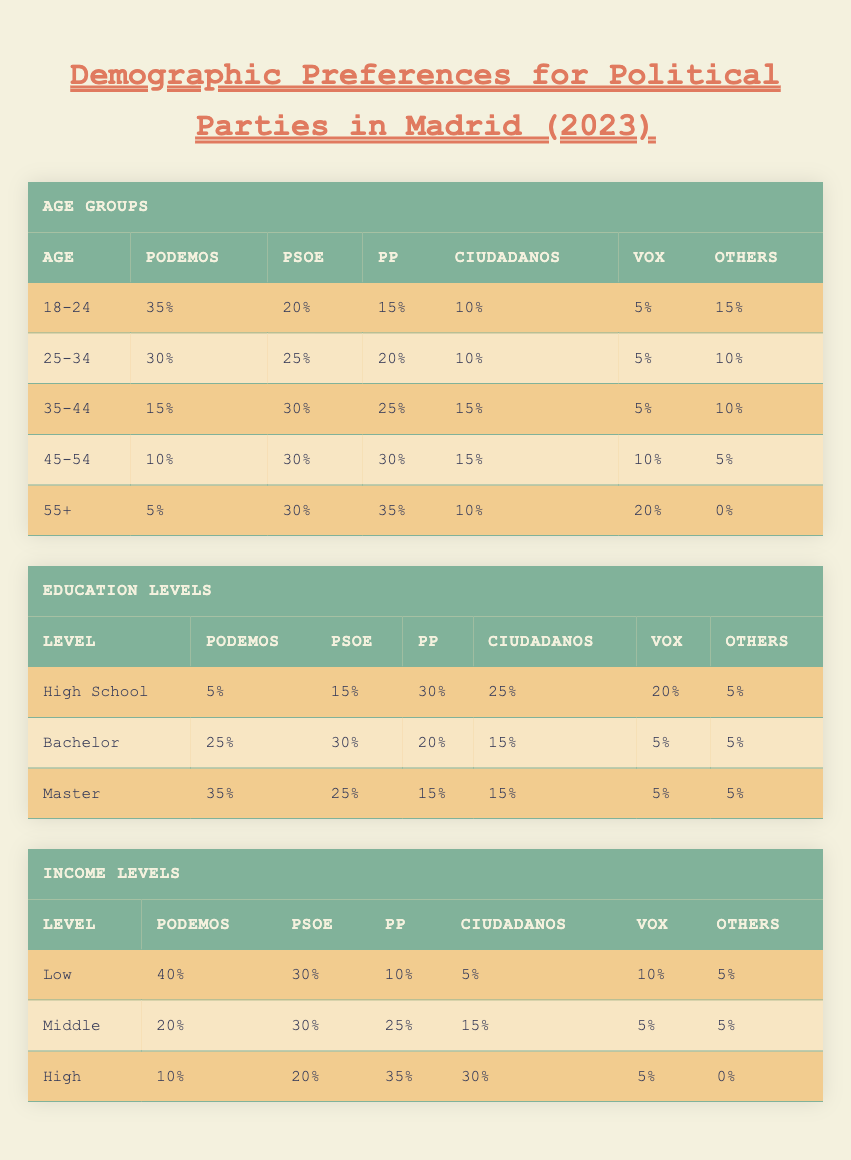What percentage of 18-24 year-olds support Podemos? Referring to the table, under the "Age Groups" section for the "18-24" category, Podemos has a support rate of 35%.
Answer: 35% Which party has the highest support among 45-54 year-olds? Looking at the "Age Groups" table for the "45-54" category, both PP and PSOE each have a support rate of 30%, which is the highest among this age group.
Answer: PP and PSOE What is the total support percentage for PSOE across all age groups? To find this, we sum the percentages of PSOE from each age group: 20 + 25 + 30 + 30 + 30 = 135.
Answer: 135% Do more people with a Master's degree support Podemos than those with a Bachelor's degree? The table for "Education Levels" shows that Podemos has 35% support among those with a Master’s degree, while it has 25% support among those with a Bachelor's degree. Therefore, it is true that more Master’s degree holders support Podemos.
Answer: Yes What is the average support for PP across all income levels? The percentages for PP across the income levels are 10% (Low), 25% (Middle), and 35% (High). To find the average, sum these values (10 + 25 + 35 = 70) and divide by the number of income levels (70 / 3 = 23.33).
Answer: 23.33 Which political party has the lowest support among the "High School" education group? In the "Education Levels" table under "High School," Podemos has the lowest support at 5%, compared to other parties listed.
Answer: Podemos Do 25-34 year-olds have more support for PSOE than 35-44 year-olds? For 25-34 year-olds, PSOE has a support rate of 25%, while for the 35-44 year-olds, it has a support rate of 30%. This indicates that 35-44 year-olds have higher support for PSOE compared to the 25-34 age group.
Answer: No Which income level has the highest support for Podemos? In the "Income Levels" section, Podemos has 40% support among the Low income group, which is indeed the highest support compared to the other income levels listed.
Answer: Low What is the difference in support for PP between the 55+ age group and the High-income level? PP has 35% support in the 55+ age group and 35% support in the High-income category. The difference is 35 - 35 = 0%.
Answer: 0% 